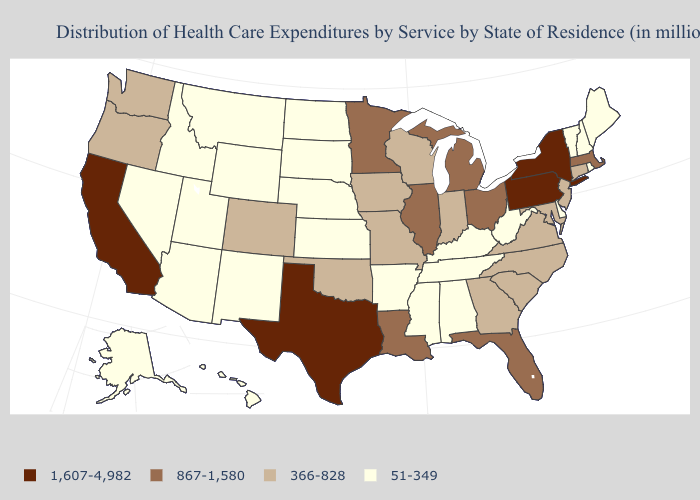Among the states that border Pennsylvania , which have the lowest value?
Keep it brief. Delaware, West Virginia. Does Texas have the lowest value in the USA?
Give a very brief answer. No. Does Montana have the same value as Rhode Island?
Short answer required. Yes. Name the states that have a value in the range 51-349?
Be succinct. Alabama, Alaska, Arizona, Arkansas, Delaware, Hawaii, Idaho, Kansas, Kentucky, Maine, Mississippi, Montana, Nebraska, Nevada, New Hampshire, New Mexico, North Dakota, Rhode Island, South Dakota, Tennessee, Utah, Vermont, West Virginia, Wyoming. Name the states that have a value in the range 867-1,580?
Give a very brief answer. Florida, Illinois, Louisiana, Massachusetts, Michigan, Minnesota, Ohio. Name the states that have a value in the range 867-1,580?
Be succinct. Florida, Illinois, Louisiana, Massachusetts, Michigan, Minnesota, Ohio. Among the states that border Iowa , which have the highest value?
Keep it brief. Illinois, Minnesota. Which states have the highest value in the USA?
Concise answer only. California, New York, Pennsylvania, Texas. Does Minnesota have a higher value than Massachusetts?
Quick response, please. No. Does Delaware have the highest value in the USA?
Give a very brief answer. No. Among the states that border New York , does Connecticut have the highest value?
Short answer required. No. Name the states that have a value in the range 366-828?
Short answer required. Colorado, Connecticut, Georgia, Indiana, Iowa, Maryland, Missouri, New Jersey, North Carolina, Oklahoma, Oregon, South Carolina, Virginia, Washington, Wisconsin. Among the states that border Vermont , which have the lowest value?
Be succinct. New Hampshire. What is the value of Connecticut?
Answer briefly. 366-828. What is the value of Wyoming?
Quick response, please. 51-349. 